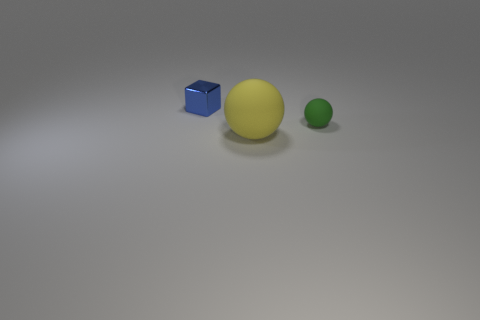Add 1 tiny brown blocks. How many objects exist? 4 Subtract all green balls. How many balls are left? 1 Subtract all spheres. How many objects are left? 1 Subtract all metal objects. Subtract all metal blocks. How many objects are left? 1 Add 3 large objects. How many large objects are left? 4 Add 1 green balls. How many green balls exist? 2 Subtract 0 purple spheres. How many objects are left? 3 Subtract all yellow blocks. Subtract all yellow cylinders. How many blocks are left? 1 